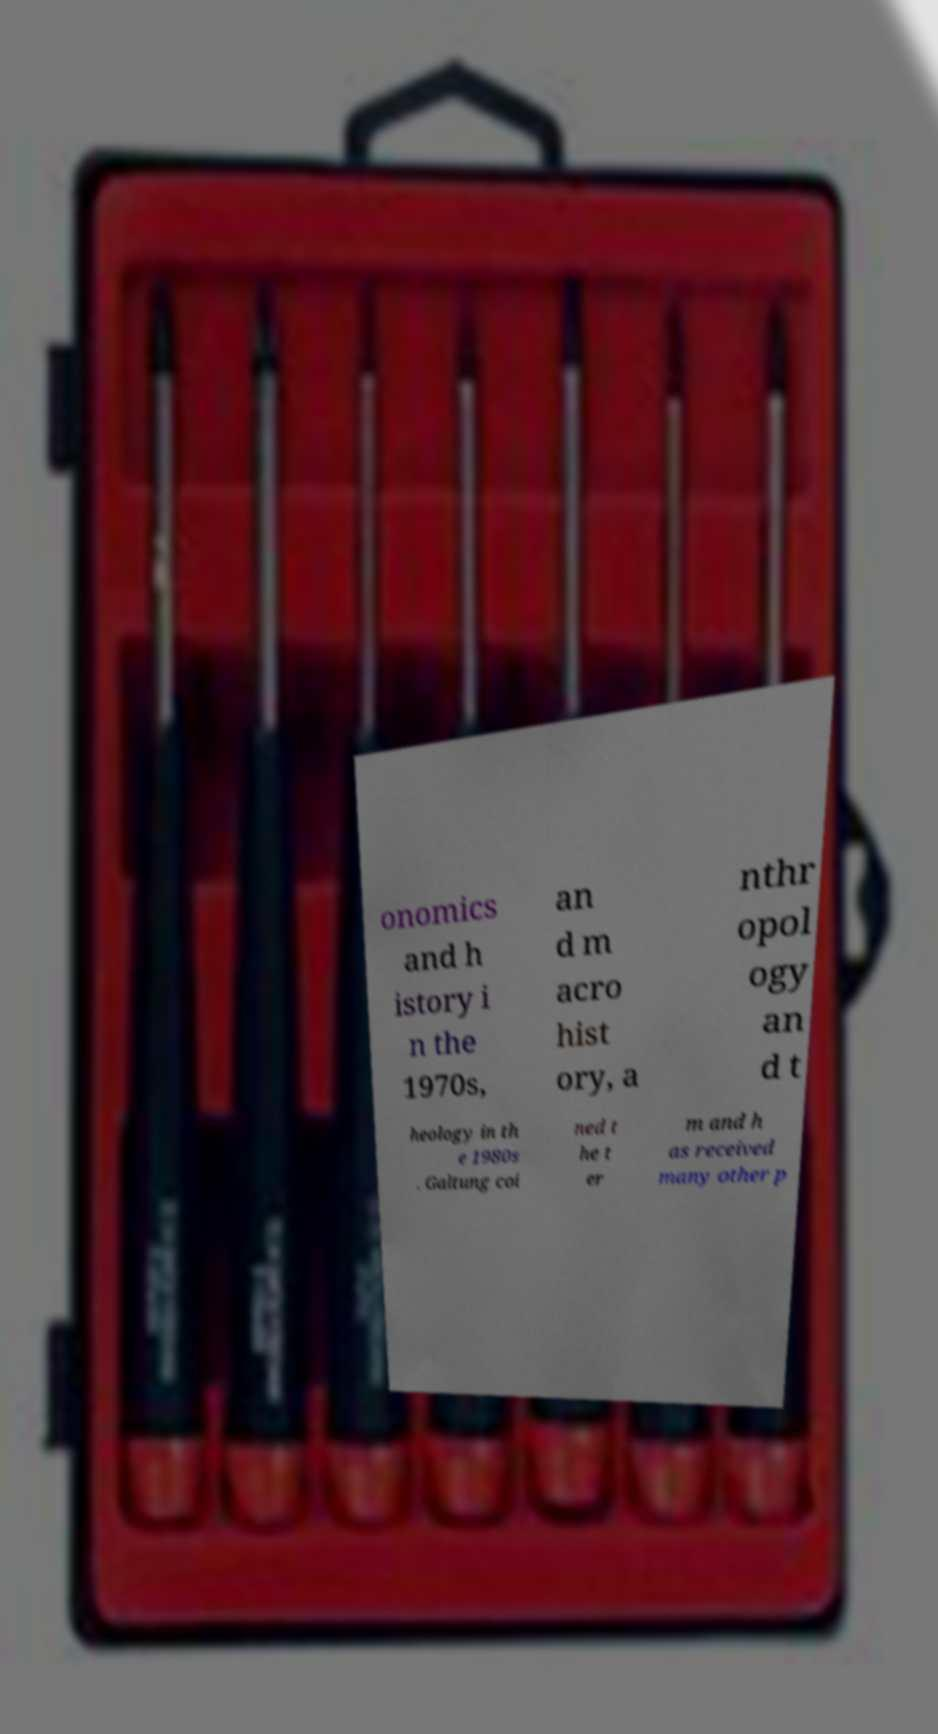There's text embedded in this image that I need extracted. Can you transcribe it verbatim? onomics and h istory i n the 1970s, an d m acro hist ory, a nthr opol ogy an d t heology in th e 1980s . Galtung coi ned t he t er m and h as received many other p 